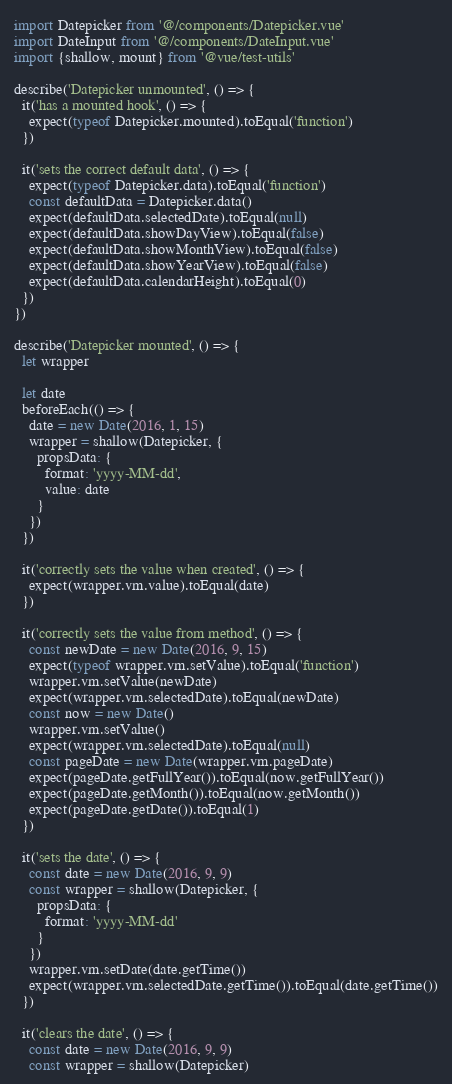Convert code to text. <code><loc_0><loc_0><loc_500><loc_500><_JavaScript_>import Datepicker from '@/components/Datepicker.vue'
import DateInput from '@/components/DateInput.vue'
import {shallow, mount} from '@vue/test-utils'

describe('Datepicker unmounted', () => {
  it('has a mounted hook', () => {
    expect(typeof Datepicker.mounted).toEqual('function')
  })

  it('sets the correct default data', () => {
    expect(typeof Datepicker.data).toEqual('function')
    const defaultData = Datepicker.data()
    expect(defaultData.selectedDate).toEqual(null)
    expect(defaultData.showDayView).toEqual(false)
    expect(defaultData.showMonthView).toEqual(false)
    expect(defaultData.showYearView).toEqual(false)
    expect(defaultData.calendarHeight).toEqual(0)
  })
})

describe('Datepicker mounted', () => {
  let wrapper

  let date
  beforeEach(() => {
    date = new Date(2016, 1, 15)
    wrapper = shallow(Datepicker, {
      propsData: {
        format: 'yyyy-MM-dd',
        value: date
      }
    })
  })

  it('correctly sets the value when created', () => {
    expect(wrapper.vm.value).toEqual(date)
  })

  it('correctly sets the value from method', () => {
    const newDate = new Date(2016, 9, 15)
    expect(typeof wrapper.vm.setValue).toEqual('function')
    wrapper.vm.setValue(newDate)
    expect(wrapper.vm.selectedDate).toEqual(newDate)
    const now = new Date()
    wrapper.vm.setValue()
    expect(wrapper.vm.selectedDate).toEqual(null)
    const pageDate = new Date(wrapper.vm.pageDate)
    expect(pageDate.getFullYear()).toEqual(now.getFullYear())
    expect(pageDate.getMonth()).toEqual(now.getMonth())
    expect(pageDate.getDate()).toEqual(1)
  })

  it('sets the date', () => {
    const date = new Date(2016, 9, 9)
    const wrapper = shallow(Datepicker, {
      propsData: {
        format: 'yyyy-MM-dd'
      }
    })
    wrapper.vm.setDate(date.getTime())
    expect(wrapper.vm.selectedDate.getTime()).toEqual(date.getTime())
  })

  it('clears the date', () => {
    const date = new Date(2016, 9, 9)
    const wrapper = shallow(Datepicker)</code> 